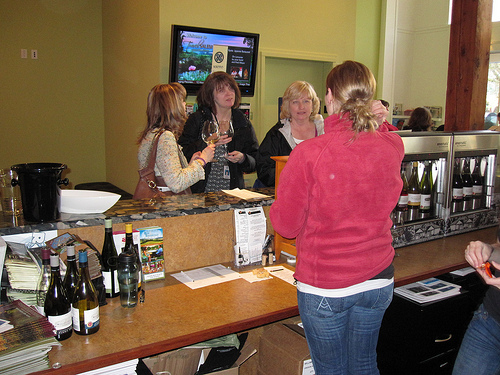<image>
Can you confirm if the purse is behind the woman? No. The purse is not behind the woman. From this viewpoint, the purse appears to be positioned elsewhere in the scene. Is the bottle in front of the tv? Yes. The bottle is positioned in front of the tv, appearing closer to the camera viewpoint. 